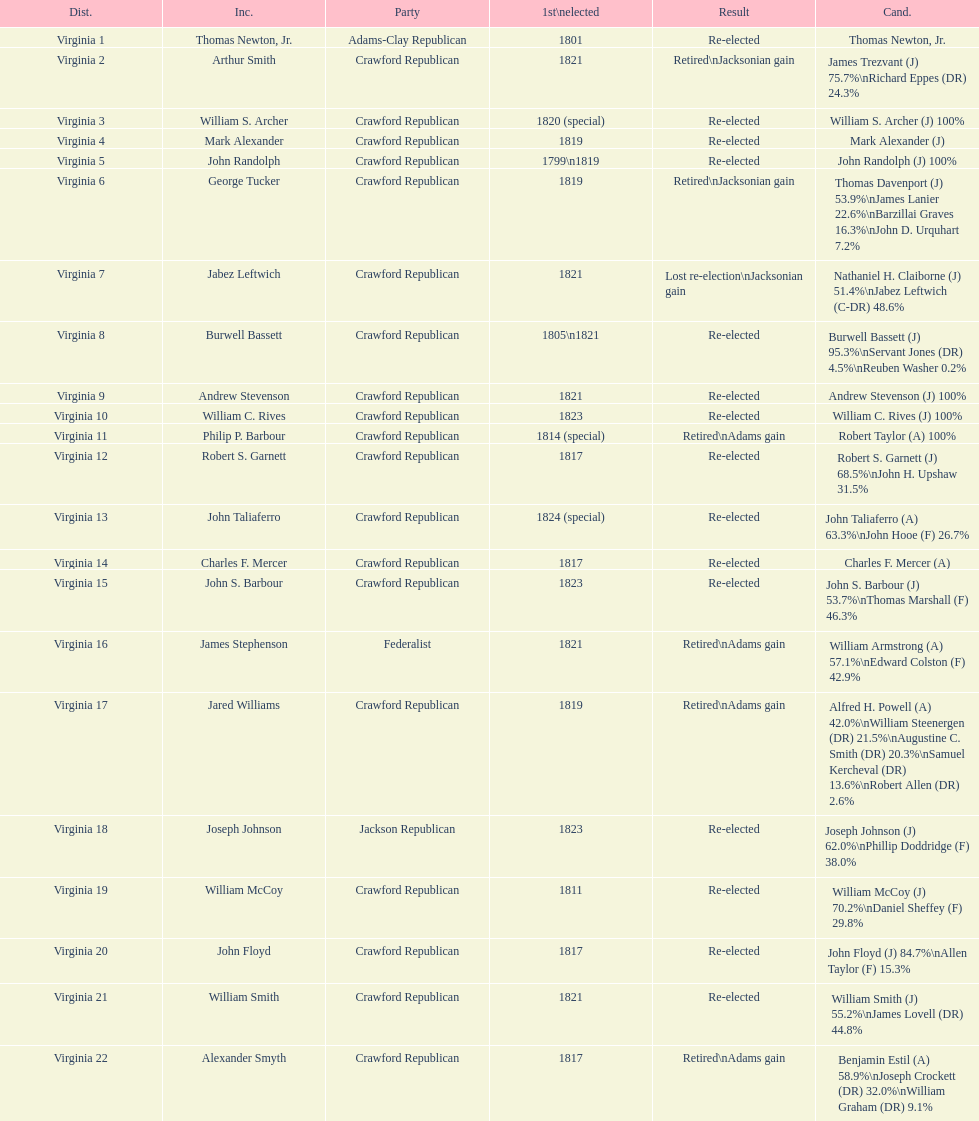Which incumbents belonged to the crawford republican party? Arthur Smith, William S. Archer, Mark Alexander, John Randolph, George Tucker, Jabez Leftwich, Burwell Bassett, Andrew Stevenson, William C. Rives, Philip P. Barbour, Robert S. Garnett, John Taliaferro, Charles F. Mercer, John S. Barbour, Jared Williams, William McCoy, John Floyd, William Smith, Alexander Smyth. Which of these incumbents were first elected in 1821? Arthur Smith, Jabez Leftwich, Andrew Stevenson, William Smith. Which of these incumbents have a last name of smith? Arthur Smith, William Smith. Which of these two were not re-elected? Arthur Smith. 